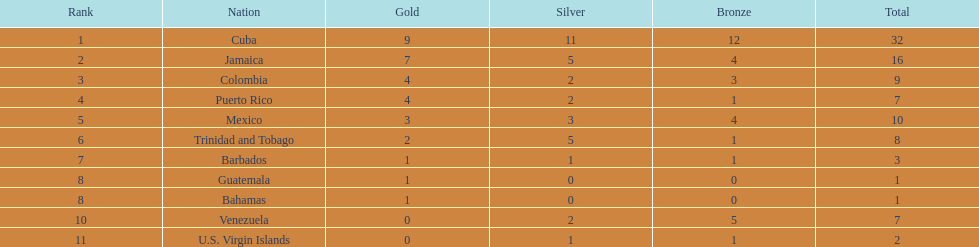What country has a record of winning 4 or more gold medals? Cuba, Jamaica, Colombia, Puerto Rico. Out of these countries, who has the smallest count of bronze medals? Puerto Rico. 